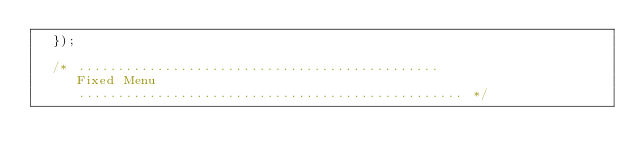Convert code to text. <code><loc_0><loc_0><loc_500><loc_500><_JavaScript_>	});

	/* ..............................................
	   Fixed Menu
	   ................................................. */
</code> 